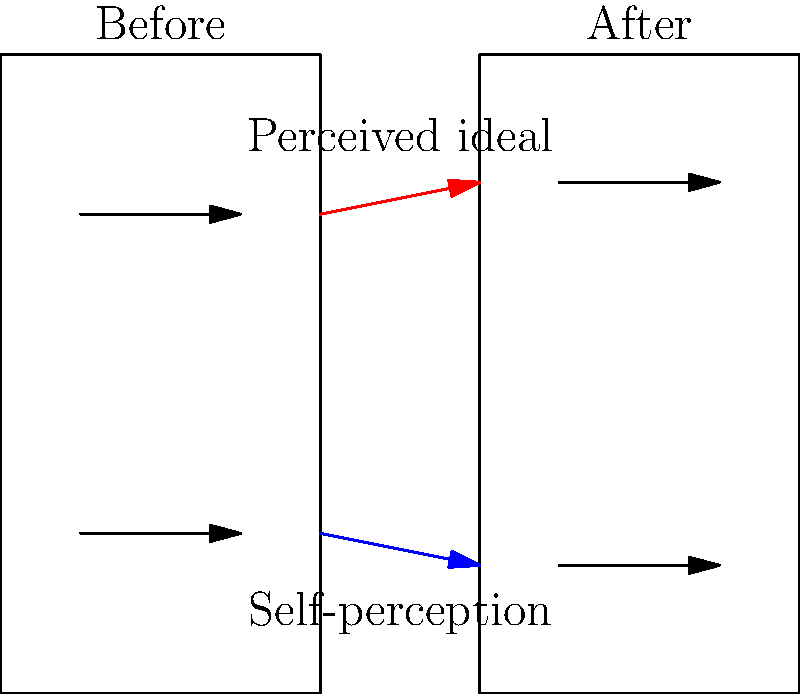Analyze the psychological impact of altered body images using the before and after photo comparisons shown. How might the discrepancy between perceived ideal and self-perception affect an individual's body image and mental health in the modeling industry? Discuss potential coping mechanisms and interventions to address these issues. 1. Analyze the diagram:
   - The "Before" photo shows a smaller gap between perceived ideal and self-perception.
   - The "After" photo shows an increased gap between perceived ideal and self-perception.

2. Psychological impact:
   a) Increased body dissatisfaction: The widening gap may lead to greater dissatisfaction with one's appearance.
   b) Lowered self-esteem: Feeling unable to meet the perceived ideal can negatively impact self-worth.
   c) Anxiety and depression: Constant pressure to achieve an unrealistic ideal may contribute to mental health issues.
   d) Body dysmorphia: Persistent focus on perceived flaws can lead to a distorted self-image.

3. Industry-specific factors:
   - High-pressure environment of the modeling industry may exacerbate these issues.
   - Constant exposure to altered images can skew perception of realistic body standards.

4. Coping mechanisms and interventions:
   a) Cognitive Behavioral Therapy (CBT): Helps identify and challenge negative thought patterns.
   b) Body positivity practices: Focusing on body functionality and self-acceptance.
   c) Media literacy: Understanding the prevalence and impact of altered images.
   d) Support groups: Sharing experiences with others in the industry.
   e) Setting realistic goals: Focusing on health rather than appearance.

5. Industry-level interventions:
   - Promoting diverse body types in modeling.
   - Implementing regulations on image alteration.
   - Providing mental health resources for models.

The psychological impact of altered body images in the modeling industry can be significant, potentially leading to body dissatisfaction, lowered self-esteem, and mental health issues. Addressing these impacts requires both individual coping strategies and industry-wide changes to promote healthier body image perceptions.
Answer: Increased body dissatisfaction, lowered self-esteem, and potential mental health issues; coping through therapy, body positivity, media literacy, and support groups; industry changes needed. 